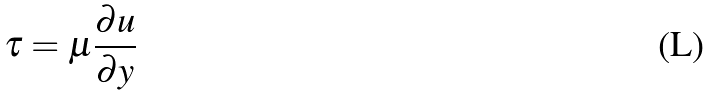Convert formula to latex. <formula><loc_0><loc_0><loc_500><loc_500>\tau = \mu \frac { \partial u } { \partial y }</formula> 